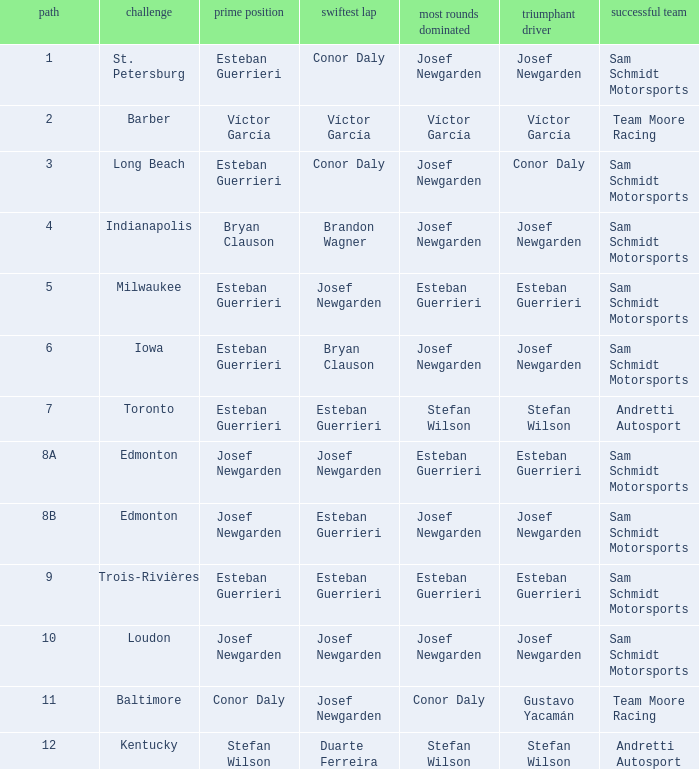Who had the fastest lap(s) when josef newgarden led the most laps at edmonton? Esteban Guerrieri. 